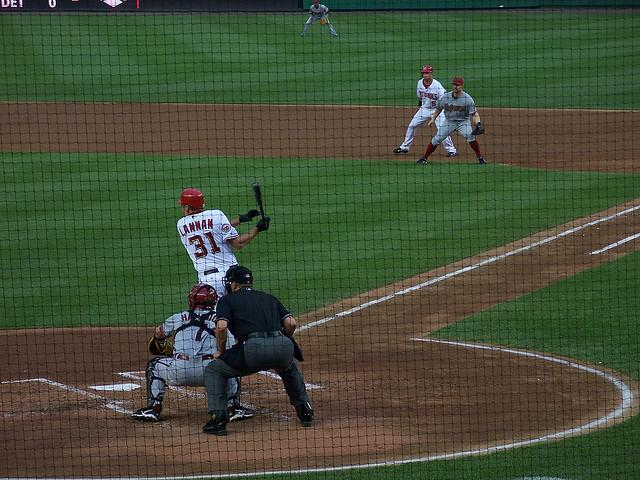What base is the player in white behind the grey suited player supposed to be on?

Choices:
A) first base
B) second base
C) home base
D) third base first base 